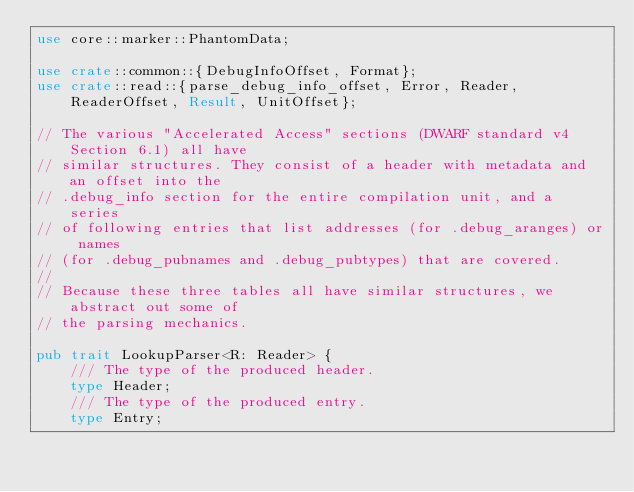<code> <loc_0><loc_0><loc_500><loc_500><_Rust_>use core::marker::PhantomData;

use crate::common::{DebugInfoOffset, Format};
use crate::read::{parse_debug_info_offset, Error, Reader, ReaderOffset, Result, UnitOffset};

// The various "Accelerated Access" sections (DWARF standard v4 Section 6.1) all have
// similar structures. They consist of a header with metadata and an offset into the
// .debug_info section for the entire compilation unit, and a series
// of following entries that list addresses (for .debug_aranges) or names
// (for .debug_pubnames and .debug_pubtypes) that are covered.
//
// Because these three tables all have similar structures, we abstract out some of
// the parsing mechanics.

pub trait LookupParser<R: Reader> {
    /// The type of the produced header.
    type Header;
    /// The type of the produced entry.
    type Entry;
</code> 